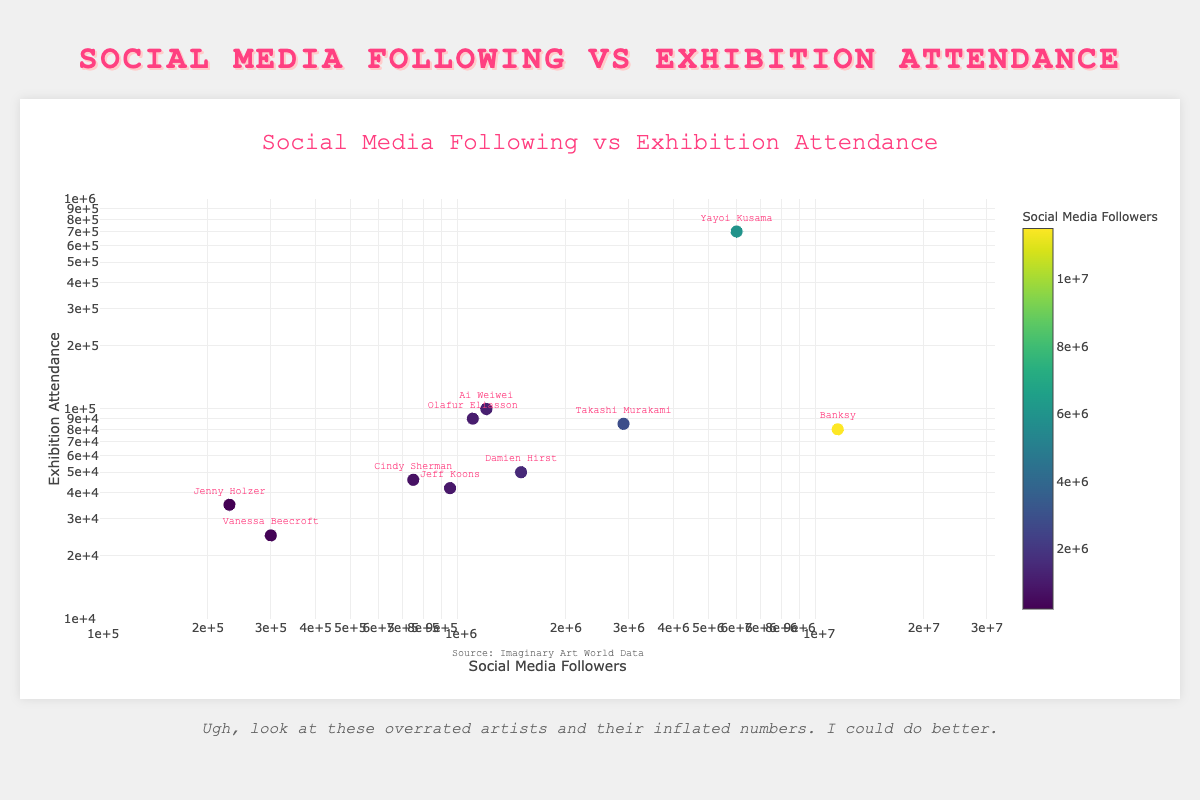What's the title of the figure? The title is prominently displayed at the top of the figure and reads "Social Media Following vs Exhibition Attendance".
Answer: Social Media Following vs Exhibition Attendance What are the x-axis and y-axis labels in this plot? The labels can be found near each axis. The x-axis is labeled "Social Media Followers" and the y-axis is labeled "Exhibition Attendance".
Answer: Social Media Followers and Exhibition Attendance How many artists have their data points in the chart? Count the artists' names available in the data, each represented as a unique point in the plot. There are 10 artists listed.
Answer: 10 Which artist has the highest social media followers, and how many do they have? From the plot's data, Banksy has the highest number of social media followers. He has 11,500,000 followers.
Answer: Banksy, 11,500,000 Which artist has the highest exhibition attendance, and how many do they have? Yayoi Kusama, depicted in the plot, has the highest exhibition attendance with 700,000 attendees.
Answer: Yayoi Kusama, 700,000 Who has more social media followers: Jeff Koons or Cindy Sherman? Refer to the plot to see their respective social media followers. Jeff Koons has 950,000 followers, while Cindy Sherman has 750,000. Therefore, Jeff Koons has more followers.
Answer: Jeff Koons What is the average exhibition attendance for the artists depicted in the plot? Add up all the exhibition attendance numbers and divide by the total number of artists: (80000 + 700000 + 85000 + 50000 + 100000 + 46000 + 42000 + 35000 + 25000 + 90000) / 10 = 1198000 / 10. The average is 119,800
Answer: 119,800 Which artist has the smallest social media following, and how many followers do they have? The plot shows that Jenny Holzer has the smallest social media following with 230,000 followers.
Answer: Jenny Holzer, 230,000 Which artist has more exhibition attendance: Olafur Eliasson or Ai Weiwei? Refer to the plot to compare their exhibition attendance. Olafur Eliasson has 90,000 attendees while Ai Weiwei has 100,000 attendees. Thus, Ai Weiwei has more.
Answer: Ai Weiwei 